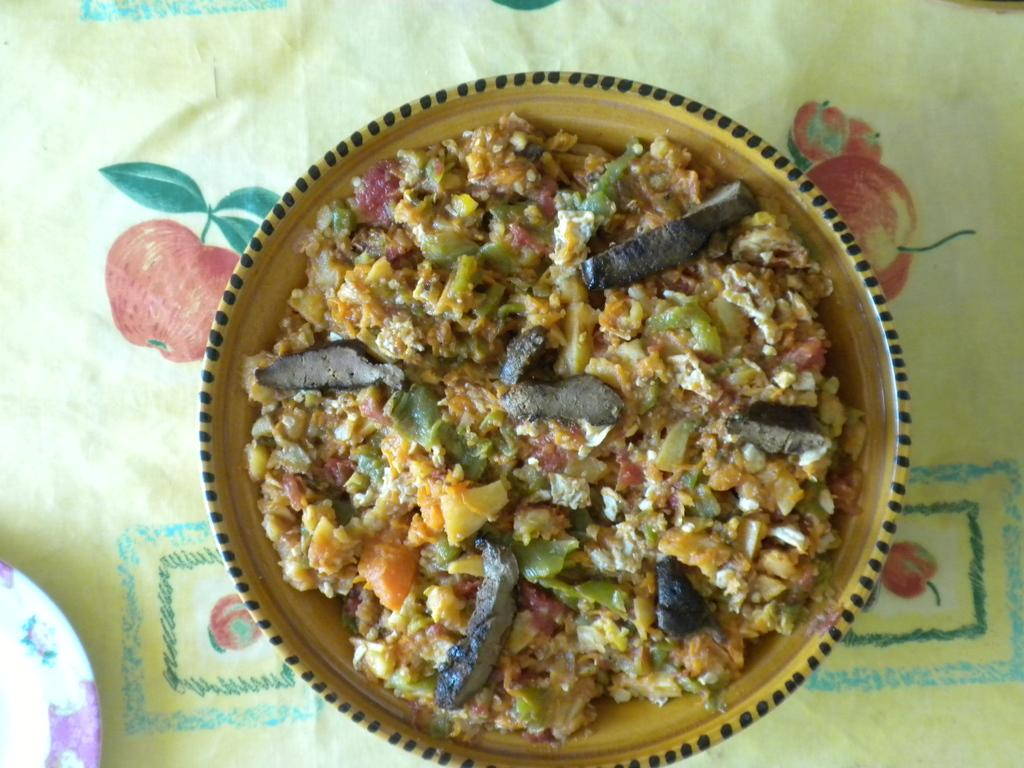What is on the plate that is visible in the image? There is a food item on a plate in the image. How many plates can be seen in the image? There are two plates visible in the image. What is the second plate placed on? The other plate is on a cloth. How does the food item on the plate jump in the image? The food item on the plate does not jump in the image; it is stationary on the plate. Is there a zipper on the cloth where the second plate is placed? There is no mention of a zipper or any clothing item in the image; it only features two plates. 